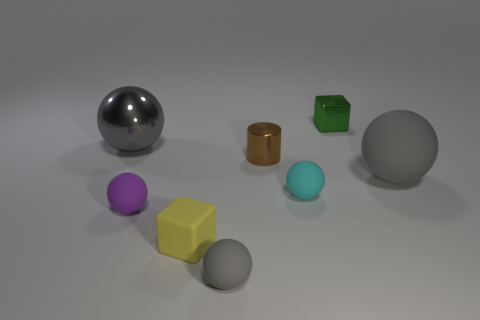How many gray balls must be subtracted to get 1 gray balls? 2 Add 1 gray rubber cubes. How many objects exist? 9 Subtract all cyan balls. How many balls are left? 4 Subtract all cylinders. How many objects are left? 7 Subtract 4 balls. How many balls are left? 1 Subtract all brown balls. How many yellow cylinders are left? 0 Subtract all cyan things. Subtract all cyan matte objects. How many objects are left? 6 Add 5 cubes. How many cubes are left? 7 Add 1 small rubber balls. How many small rubber balls exist? 4 Subtract all green blocks. How many blocks are left? 1 